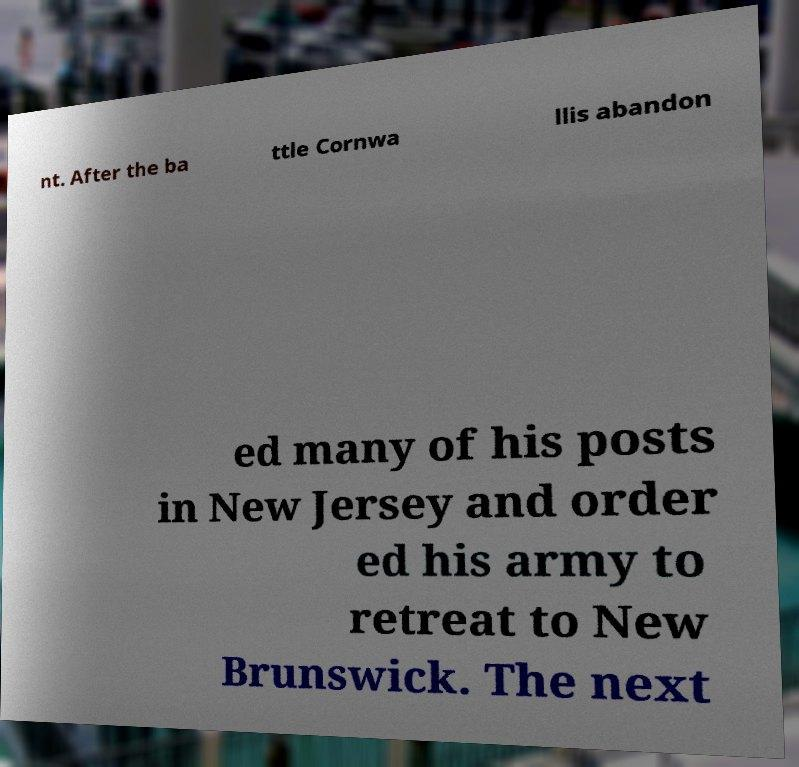What messages or text are displayed in this image? I need them in a readable, typed format. nt. After the ba ttle Cornwa llis abandon ed many of his posts in New Jersey and order ed his army to retreat to New Brunswick. The next 